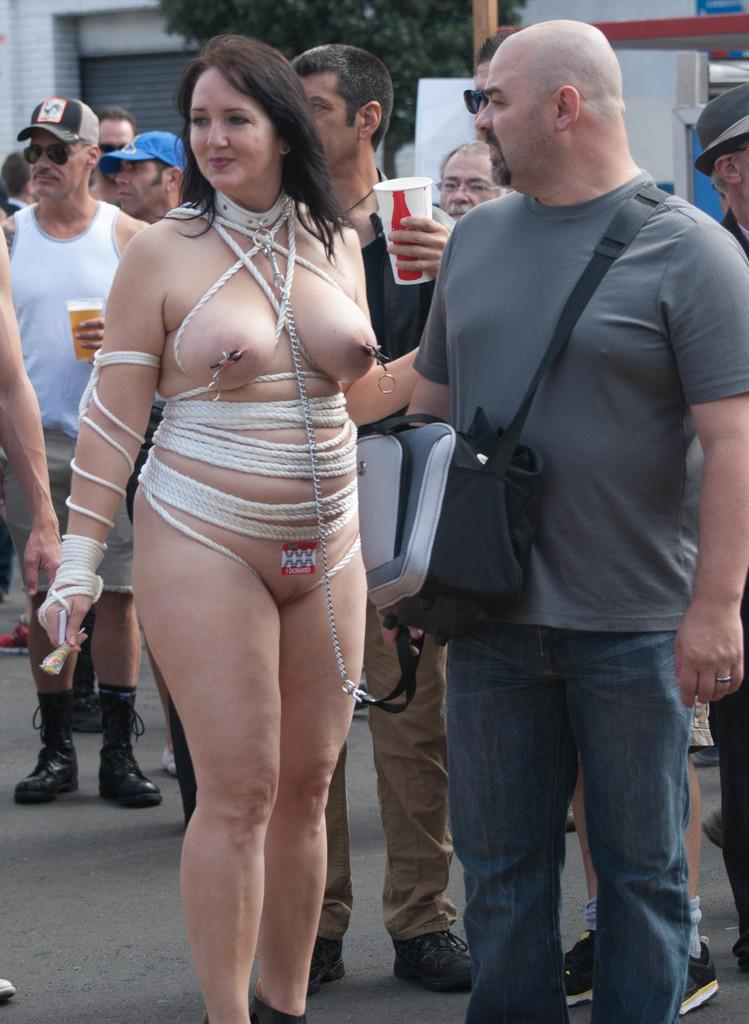How many people are in the image? There is a group of people in the image, but the exact number cannot be determined from the provided facts. What is visible in the background of the image? There is a wall and trees in the background of the image. What type of beast is drawing the attention of the group in the image? There is no beast present in the image, and therefore no such interaction can be observed. 